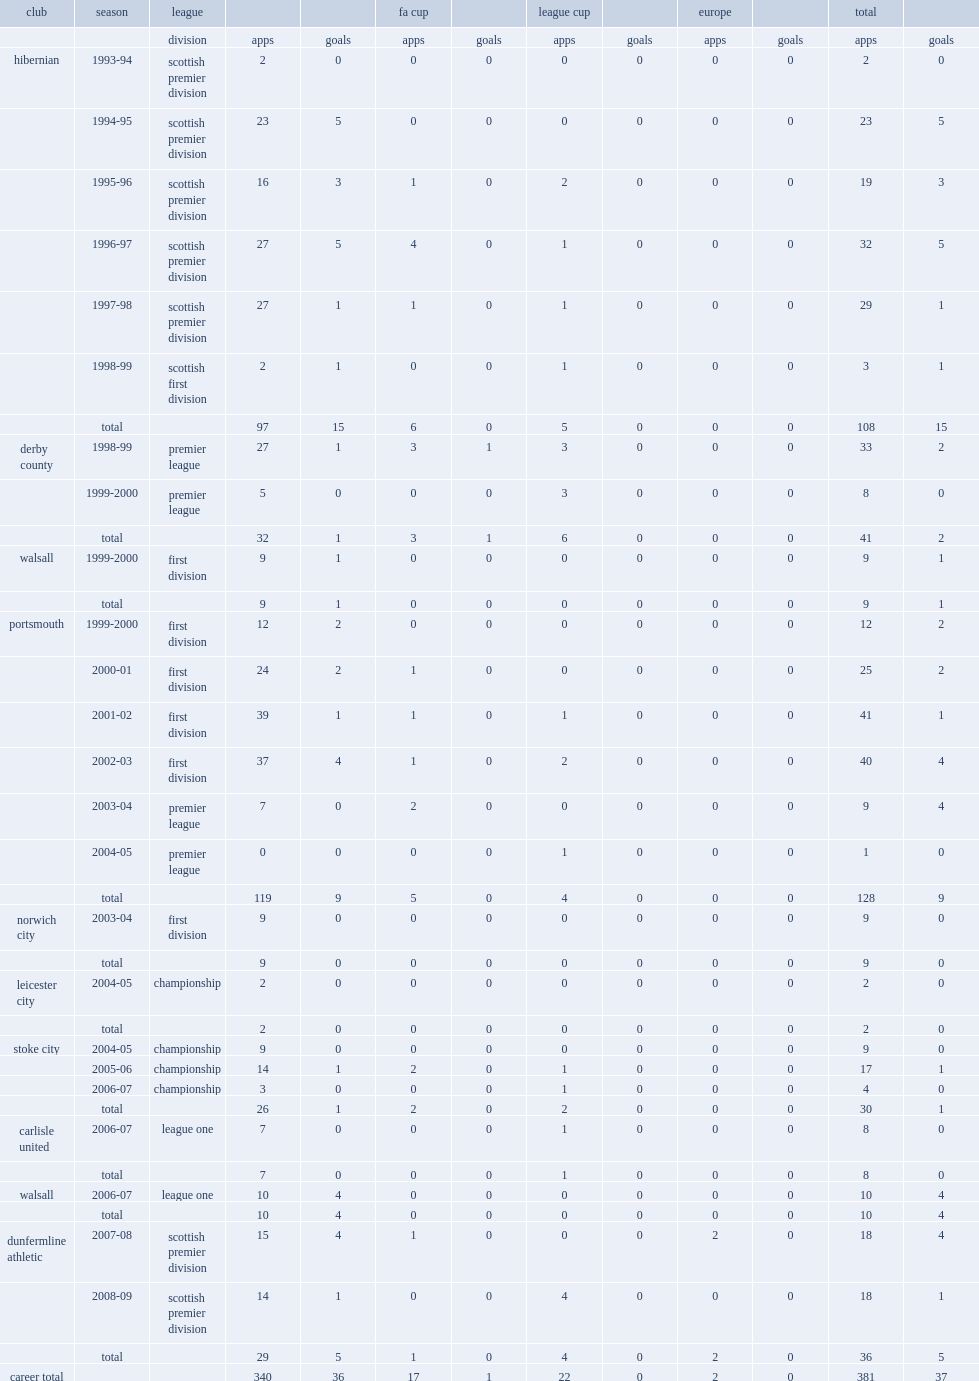Which club did kevin harper play for in 2002-03? Portsmouth. 